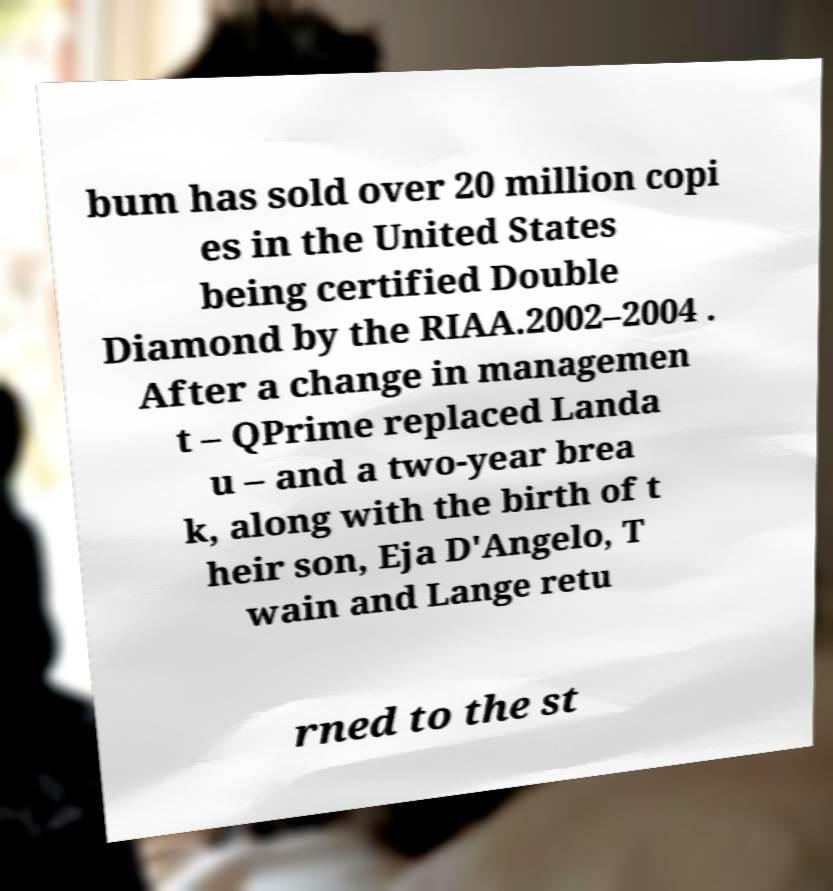Please read and relay the text visible in this image. What does it say? bum has sold over 20 million copi es in the United States being certified Double Diamond by the RIAA.2002–2004 . After a change in managemen t – QPrime replaced Landa u – and a two-year brea k, along with the birth of t heir son, Eja D'Angelo, T wain and Lange retu rned to the st 